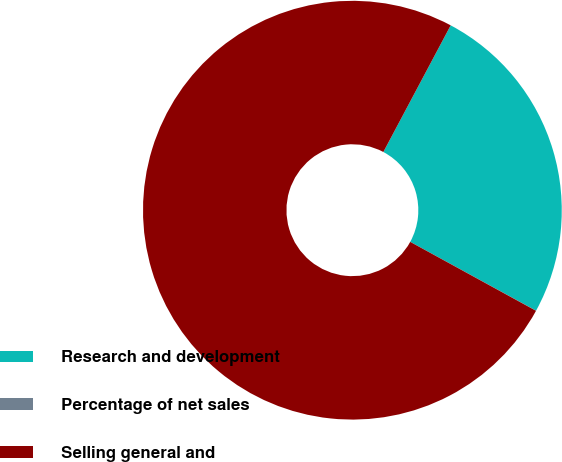<chart> <loc_0><loc_0><loc_500><loc_500><pie_chart><fcel>Research and development<fcel>Percentage of net sales<fcel>Selling general and<nl><fcel>25.19%<fcel>0.01%<fcel>74.8%<nl></chart> 